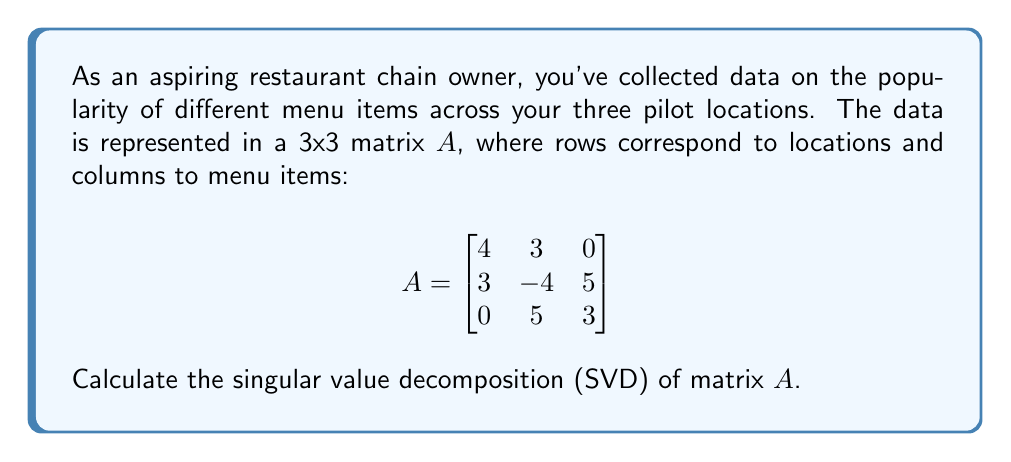What is the answer to this math problem? To find the singular value decomposition of matrix $A$, we need to find matrices $U$, $\Sigma$, and $V^T$ such that $A = U\Sigma V^T$.

Step 1: Calculate $A^TA$ and $AA^T$
$$A^TA = \begin{bmatrix}
25 & 0 & 15 \\
0 & 50 & 15 \\
15 & 15 & 34
\end{bmatrix}$$

$$AA^T = \begin{bmatrix}
25 & 0 & 15 \\
0 & 50 & 15 \\
15 & 15 & 34
\end{bmatrix}$$

Step 2: Find eigenvalues of $A^TA$ (or $AA^T$)
The characteristic equation is:
$$(25-\lambda)(50-\lambda)(34-\lambda) - 15^2(50-\lambda) - 15^2(25-\lambda) = 0$$
Solving this equation gives us:
$\lambda_1 = 50, \lambda_2 = 34, \lambda_3 = 25$

Step 3: Calculate singular values
The singular values are the square roots of these eigenvalues:
$\sigma_1 = \sqrt{50} \approx 7.07, \sigma_2 = \sqrt{34} \approx 5.83, \sigma_3 = 5$

Step 4: Find eigenvectors of $A^TA$ to get columns of $V$
For $\lambda_1 = 50$: $v_1 = [0, 1, 0]^T$
For $\lambda_2 = 34$: $v_2 = [3, 0, 4]^T$ (normalized)
For $\lambda_3 = 25$: $v_3 = [1, 0, -\frac{3}{4}]^T$ (normalized)

Step 5: Find eigenvectors of $AA^T$ to get columns of $U$
For $\lambda_1 = 50$: $u_1 = [0, -1, 0]^T$
For $\lambda_2 = 34$: $u_2 = [3, 0, 4]^T$ (normalized)
For $\lambda_3 = 25$: $u_3 = [1, 0, -\frac{3}{4}]^T$ (normalized)

Step 6: Construct $U$, $\Sigma$, and $V^T$
$$U = \begin{bmatrix}
0 & \frac{3}{5} & \frac{4}{5} \\
-1 & 0 & 0 \\
0 & \frac{4}{5} & -\frac{3}{5}
\end{bmatrix}$$

$$\Sigma = \begin{bmatrix}
7.07 & 0 & 0 \\
0 & 5.83 & 0 \\
0 & 0 & 5
\end{bmatrix}$$

$$V^T = \begin{bmatrix}
0 & \frac{3}{5} & \frac{4}{5} \\
1 & 0 & 0 \\
0 & \frac{4}{5} & -\frac{3}{5}
\end{bmatrix}$$
Answer: $A = U\Sigma V^T$, where:
$U = \begin{bmatrix}0 & \frac{3}{5} & \frac{4}{5} \\ -1 & 0 & 0 \\ 0 & \frac{4}{5} & -\frac{3}{5}\end{bmatrix}$,
$\Sigma = \begin{bmatrix}7.07 & 0 & 0 \\ 0 & 5.83 & 0 \\ 0 & 0 & 5\end{bmatrix}$,
$V^T = \begin{bmatrix}0 & \frac{3}{5} & \frac{4}{5} \\ 1 & 0 & 0 \\ 0 & \frac{4}{5} & -\frac{3}{5}\end{bmatrix}$ 